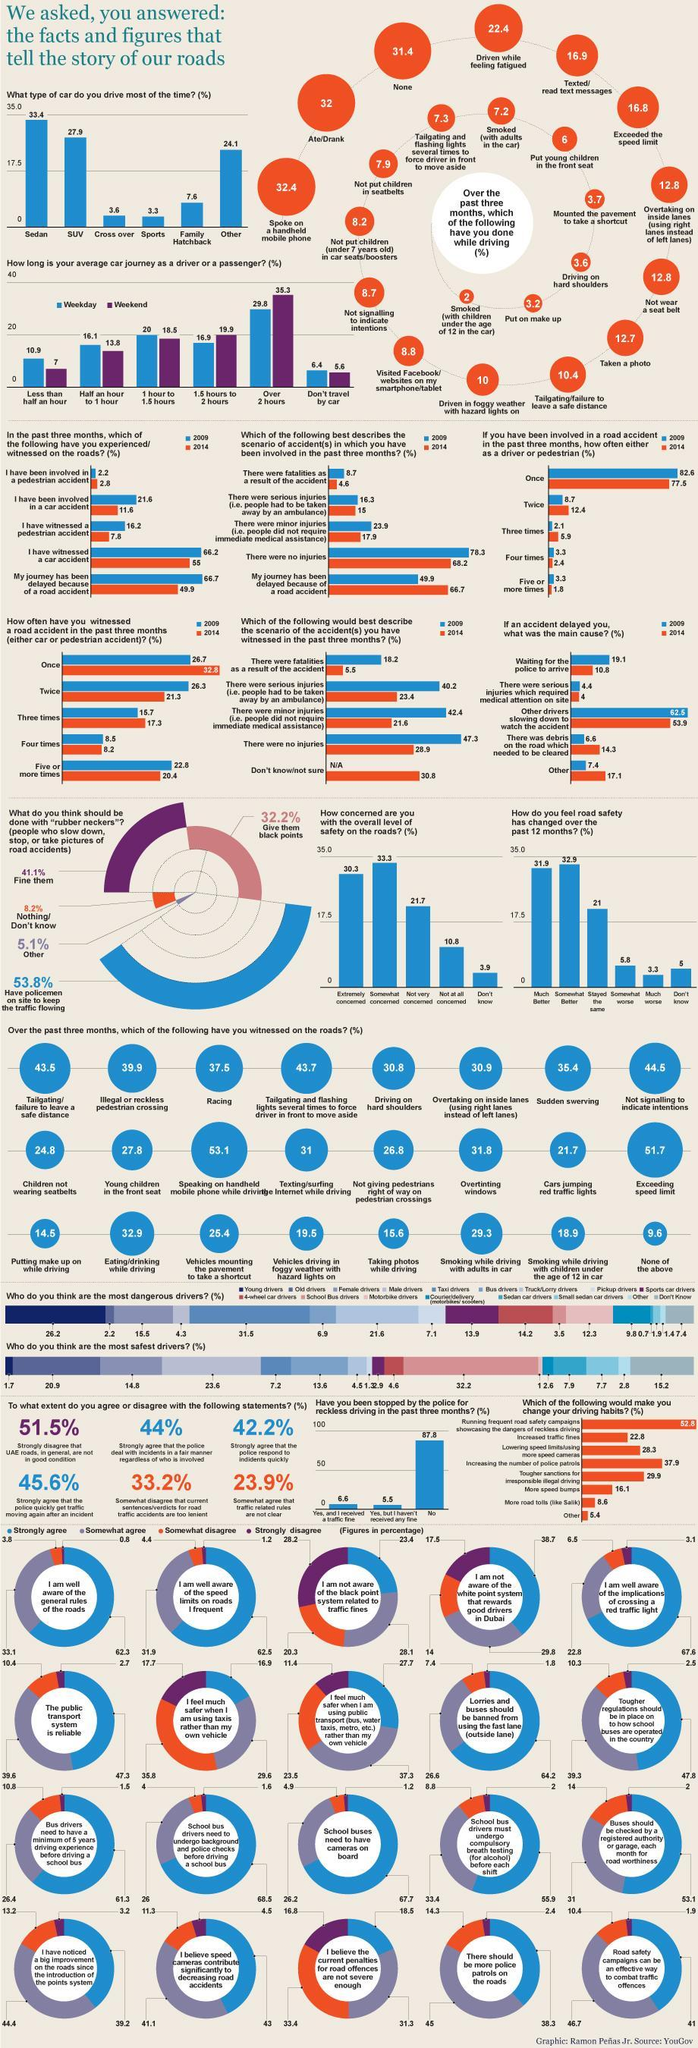What is the percentage of racing and sudden swerving when taken together?
Answer the question with a short phrase. 72.9 Which color is used to represent the weekend- orange, blue, violet, or green? violet What is the percentage of cross over and sports when taken together? 6.9% 